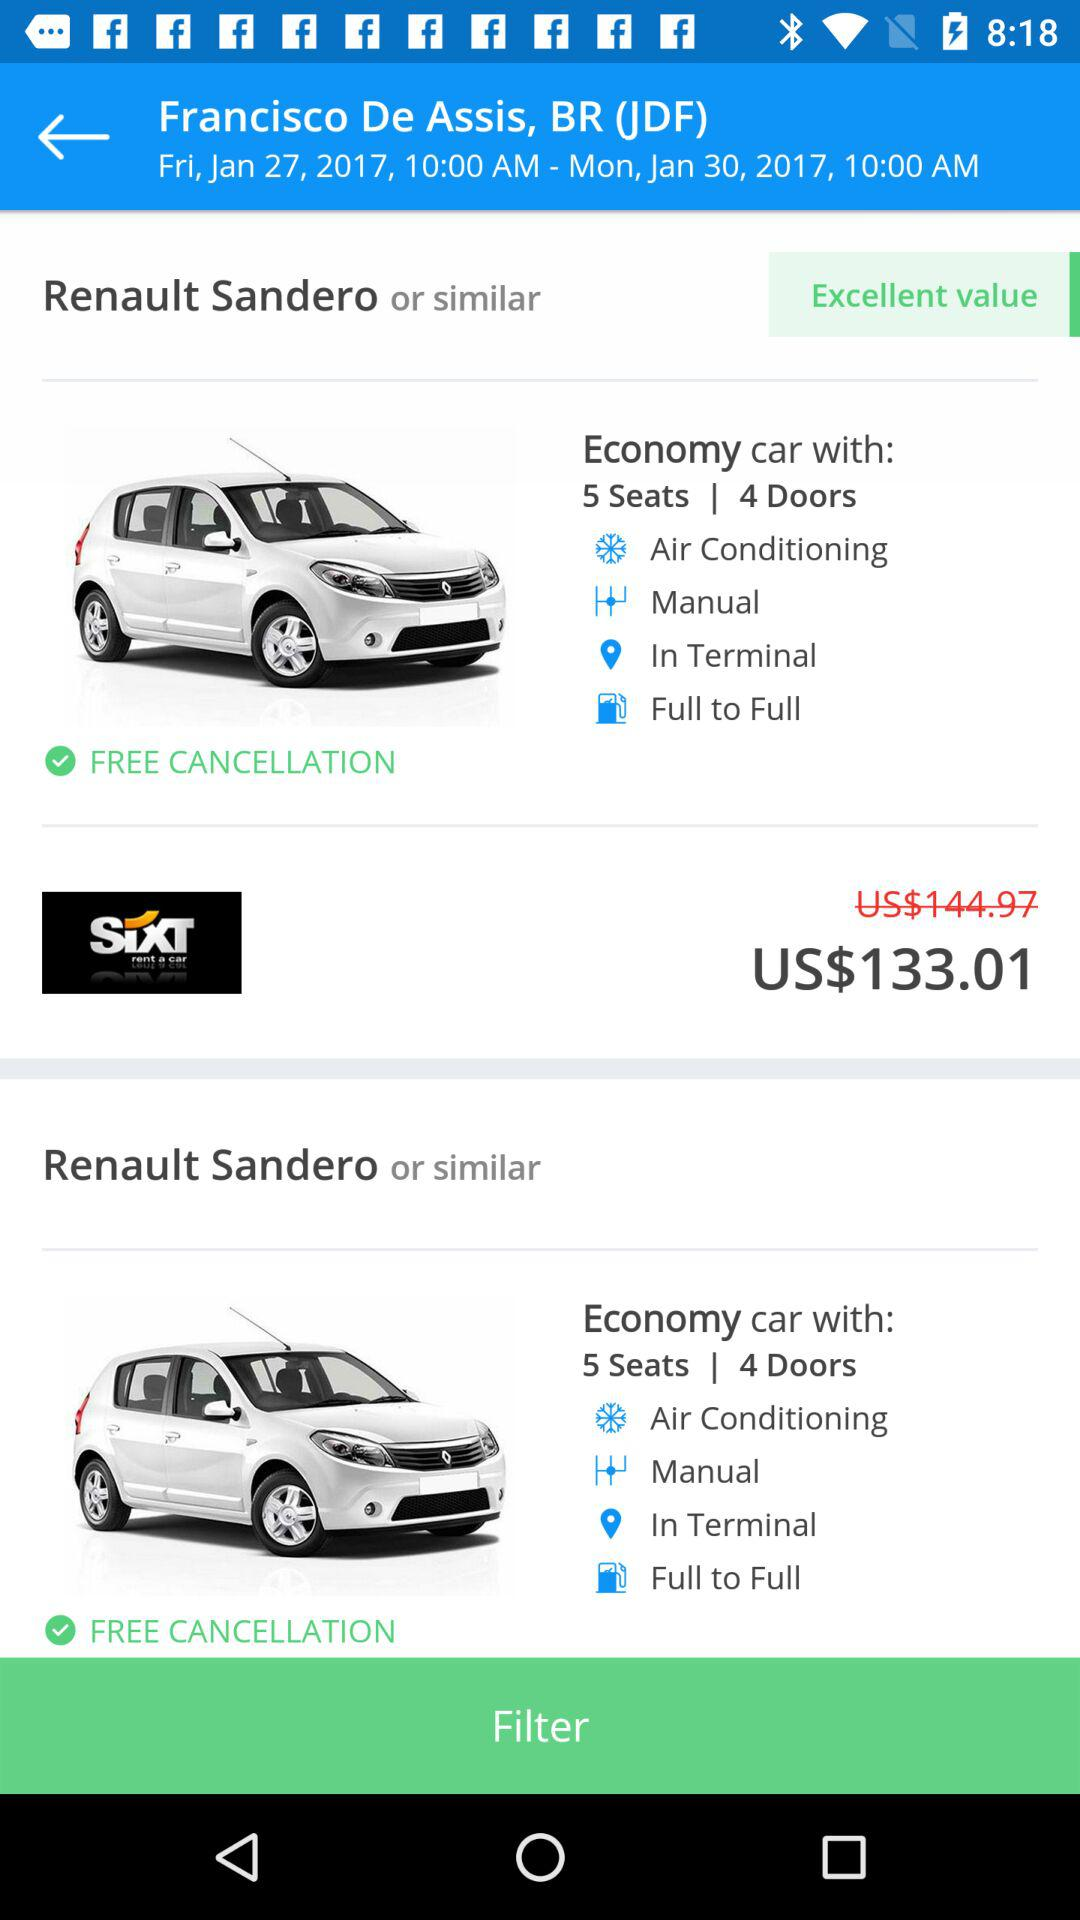What was the day on January 27, 2017? The day was Friday. 